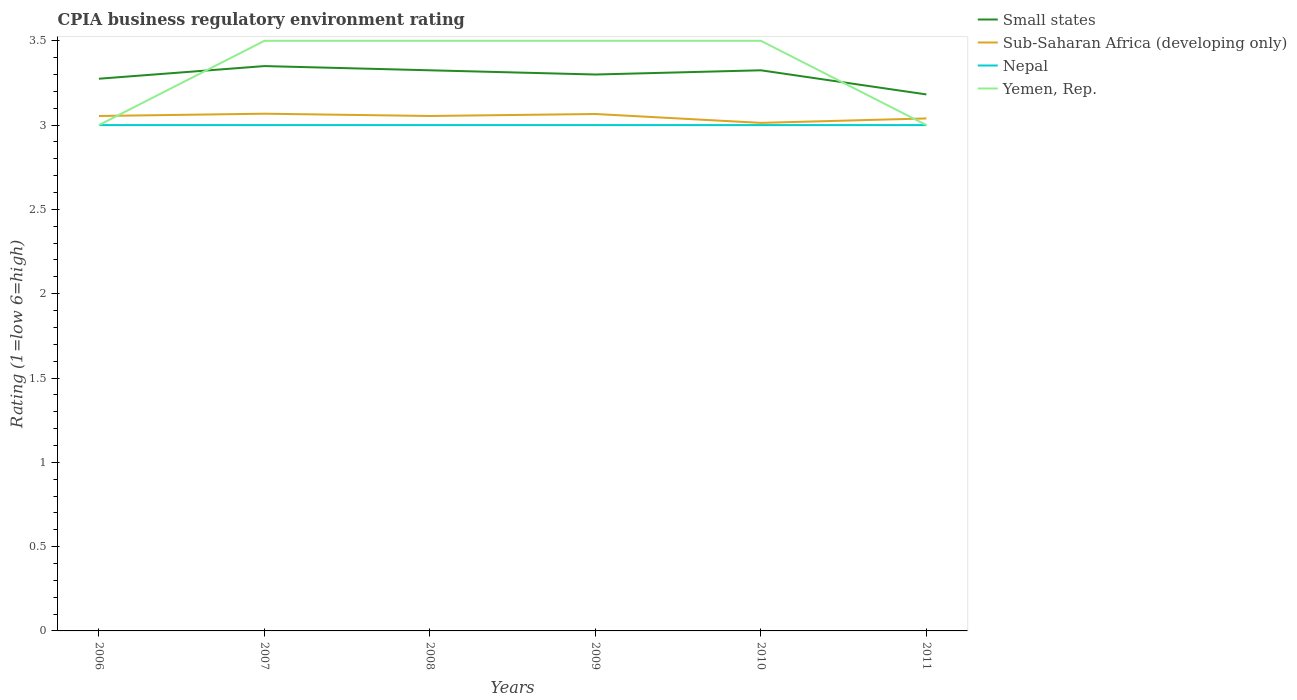How many different coloured lines are there?
Make the answer very short. 4. Does the line corresponding to Yemen, Rep. intersect with the line corresponding to Small states?
Your response must be concise. Yes. What is the total CPIA rating in Nepal in the graph?
Give a very brief answer. 0. What is the difference between the highest and the second highest CPIA rating in Small states?
Ensure brevity in your answer.  0.17. Is the CPIA rating in Small states strictly greater than the CPIA rating in Nepal over the years?
Give a very brief answer. No. How many lines are there?
Provide a succinct answer. 4. Are the values on the major ticks of Y-axis written in scientific E-notation?
Keep it short and to the point. No. Does the graph contain any zero values?
Make the answer very short. No. Does the graph contain grids?
Provide a short and direct response. No. Where does the legend appear in the graph?
Make the answer very short. Top right. How many legend labels are there?
Offer a terse response. 4. What is the title of the graph?
Offer a terse response. CPIA business regulatory environment rating. What is the label or title of the X-axis?
Your answer should be compact. Years. What is the label or title of the Y-axis?
Your answer should be very brief. Rating (1=low 6=high). What is the Rating (1=low 6=high) in Small states in 2006?
Give a very brief answer. 3.27. What is the Rating (1=low 6=high) of Sub-Saharan Africa (developing only) in 2006?
Offer a terse response. 3.05. What is the Rating (1=low 6=high) in Small states in 2007?
Provide a short and direct response. 3.35. What is the Rating (1=low 6=high) of Sub-Saharan Africa (developing only) in 2007?
Your answer should be very brief. 3.07. What is the Rating (1=low 6=high) of Yemen, Rep. in 2007?
Ensure brevity in your answer.  3.5. What is the Rating (1=low 6=high) in Small states in 2008?
Provide a short and direct response. 3.33. What is the Rating (1=low 6=high) in Sub-Saharan Africa (developing only) in 2008?
Give a very brief answer. 3.05. What is the Rating (1=low 6=high) in Nepal in 2008?
Give a very brief answer. 3. What is the Rating (1=low 6=high) in Sub-Saharan Africa (developing only) in 2009?
Offer a terse response. 3.07. What is the Rating (1=low 6=high) in Nepal in 2009?
Provide a short and direct response. 3. What is the Rating (1=low 6=high) of Small states in 2010?
Your answer should be very brief. 3.33. What is the Rating (1=low 6=high) of Sub-Saharan Africa (developing only) in 2010?
Ensure brevity in your answer.  3.01. What is the Rating (1=low 6=high) in Yemen, Rep. in 2010?
Make the answer very short. 3.5. What is the Rating (1=low 6=high) of Small states in 2011?
Keep it short and to the point. 3.18. What is the Rating (1=low 6=high) in Sub-Saharan Africa (developing only) in 2011?
Your answer should be compact. 3.04. What is the Rating (1=low 6=high) of Nepal in 2011?
Keep it short and to the point. 3. What is the Rating (1=low 6=high) of Yemen, Rep. in 2011?
Make the answer very short. 3. Across all years, what is the maximum Rating (1=low 6=high) in Small states?
Keep it short and to the point. 3.35. Across all years, what is the maximum Rating (1=low 6=high) in Sub-Saharan Africa (developing only)?
Ensure brevity in your answer.  3.07. Across all years, what is the maximum Rating (1=low 6=high) in Nepal?
Your answer should be compact. 3. Across all years, what is the minimum Rating (1=low 6=high) of Small states?
Your answer should be very brief. 3.18. Across all years, what is the minimum Rating (1=low 6=high) in Sub-Saharan Africa (developing only)?
Give a very brief answer. 3.01. Across all years, what is the minimum Rating (1=low 6=high) of Nepal?
Your response must be concise. 3. What is the total Rating (1=low 6=high) of Small states in the graph?
Your response must be concise. 19.76. What is the total Rating (1=low 6=high) in Sub-Saharan Africa (developing only) in the graph?
Make the answer very short. 18.29. What is the total Rating (1=low 6=high) in Nepal in the graph?
Your answer should be very brief. 18. What is the difference between the Rating (1=low 6=high) in Small states in 2006 and that in 2007?
Ensure brevity in your answer.  -0.07. What is the difference between the Rating (1=low 6=high) in Sub-Saharan Africa (developing only) in 2006 and that in 2007?
Offer a very short reply. -0.01. What is the difference between the Rating (1=low 6=high) in Nepal in 2006 and that in 2007?
Your answer should be compact. 0. What is the difference between the Rating (1=low 6=high) of Sub-Saharan Africa (developing only) in 2006 and that in 2008?
Provide a short and direct response. 0. What is the difference between the Rating (1=low 6=high) in Nepal in 2006 and that in 2008?
Offer a very short reply. 0. What is the difference between the Rating (1=low 6=high) of Small states in 2006 and that in 2009?
Provide a short and direct response. -0.03. What is the difference between the Rating (1=low 6=high) of Sub-Saharan Africa (developing only) in 2006 and that in 2009?
Keep it short and to the point. -0.01. What is the difference between the Rating (1=low 6=high) of Sub-Saharan Africa (developing only) in 2006 and that in 2010?
Offer a terse response. 0.04. What is the difference between the Rating (1=low 6=high) in Small states in 2006 and that in 2011?
Provide a short and direct response. 0.09. What is the difference between the Rating (1=low 6=high) of Sub-Saharan Africa (developing only) in 2006 and that in 2011?
Provide a short and direct response. 0.01. What is the difference between the Rating (1=low 6=high) in Small states in 2007 and that in 2008?
Offer a terse response. 0.03. What is the difference between the Rating (1=low 6=high) of Sub-Saharan Africa (developing only) in 2007 and that in 2008?
Provide a succinct answer. 0.01. What is the difference between the Rating (1=low 6=high) of Yemen, Rep. in 2007 and that in 2008?
Give a very brief answer. 0. What is the difference between the Rating (1=low 6=high) in Sub-Saharan Africa (developing only) in 2007 and that in 2009?
Give a very brief answer. 0. What is the difference between the Rating (1=low 6=high) in Nepal in 2007 and that in 2009?
Keep it short and to the point. 0. What is the difference between the Rating (1=low 6=high) of Small states in 2007 and that in 2010?
Provide a short and direct response. 0.03. What is the difference between the Rating (1=low 6=high) of Sub-Saharan Africa (developing only) in 2007 and that in 2010?
Offer a terse response. 0.05. What is the difference between the Rating (1=low 6=high) in Nepal in 2007 and that in 2010?
Provide a succinct answer. 0. What is the difference between the Rating (1=low 6=high) of Yemen, Rep. in 2007 and that in 2010?
Provide a short and direct response. 0. What is the difference between the Rating (1=low 6=high) in Small states in 2007 and that in 2011?
Your response must be concise. 0.17. What is the difference between the Rating (1=low 6=high) of Sub-Saharan Africa (developing only) in 2007 and that in 2011?
Ensure brevity in your answer.  0.03. What is the difference between the Rating (1=low 6=high) of Small states in 2008 and that in 2009?
Provide a short and direct response. 0.03. What is the difference between the Rating (1=low 6=high) in Sub-Saharan Africa (developing only) in 2008 and that in 2009?
Provide a short and direct response. -0.01. What is the difference between the Rating (1=low 6=high) of Sub-Saharan Africa (developing only) in 2008 and that in 2010?
Give a very brief answer. 0.04. What is the difference between the Rating (1=low 6=high) in Small states in 2008 and that in 2011?
Give a very brief answer. 0.14. What is the difference between the Rating (1=low 6=high) of Sub-Saharan Africa (developing only) in 2008 and that in 2011?
Your answer should be very brief. 0.01. What is the difference between the Rating (1=low 6=high) of Yemen, Rep. in 2008 and that in 2011?
Give a very brief answer. 0.5. What is the difference between the Rating (1=low 6=high) of Small states in 2009 and that in 2010?
Provide a succinct answer. -0.03. What is the difference between the Rating (1=low 6=high) of Sub-Saharan Africa (developing only) in 2009 and that in 2010?
Offer a terse response. 0.05. What is the difference between the Rating (1=low 6=high) of Yemen, Rep. in 2009 and that in 2010?
Offer a terse response. 0. What is the difference between the Rating (1=low 6=high) of Small states in 2009 and that in 2011?
Offer a very short reply. 0.12. What is the difference between the Rating (1=low 6=high) in Sub-Saharan Africa (developing only) in 2009 and that in 2011?
Offer a terse response. 0.03. What is the difference between the Rating (1=low 6=high) in Yemen, Rep. in 2009 and that in 2011?
Offer a very short reply. 0.5. What is the difference between the Rating (1=low 6=high) in Small states in 2010 and that in 2011?
Offer a terse response. 0.14. What is the difference between the Rating (1=low 6=high) in Sub-Saharan Africa (developing only) in 2010 and that in 2011?
Offer a very short reply. -0.03. What is the difference between the Rating (1=low 6=high) of Yemen, Rep. in 2010 and that in 2011?
Provide a succinct answer. 0.5. What is the difference between the Rating (1=low 6=high) in Small states in 2006 and the Rating (1=low 6=high) in Sub-Saharan Africa (developing only) in 2007?
Provide a succinct answer. 0.21. What is the difference between the Rating (1=low 6=high) of Small states in 2006 and the Rating (1=low 6=high) of Nepal in 2007?
Your answer should be very brief. 0.28. What is the difference between the Rating (1=low 6=high) of Small states in 2006 and the Rating (1=low 6=high) of Yemen, Rep. in 2007?
Your answer should be very brief. -0.23. What is the difference between the Rating (1=low 6=high) of Sub-Saharan Africa (developing only) in 2006 and the Rating (1=low 6=high) of Nepal in 2007?
Offer a very short reply. 0.05. What is the difference between the Rating (1=low 6=high) of Sub-Saharan Africa (developing only) in 2006 and the Rating (1=low 6=high) of Yemen, Rep. in 2007?
Your answer should be very brief. -0.45. What is the difference between the Rating (1=low 6=high) in Small states in 2006 and the Rating (1=low 6=high) in Sub-Saharan Africa (developing only) in 2008?
Provide a short and direct response. 0.22. What is the difference between the Rating (1=low 6=high) in Small states in 2006 and the Rating (1=low 6=high) in Nepal in 2008?
Provide a succinct answer. 0.28. What is the difference between the Rating (1=low 6=high) of Small states in 2006 and the Rating (1=low 6=high) of Yemen, Rep. in 2008?
Your answer should be compact. -0.23. What is the difference between the Rating (1=low 6=high) of Sub-Saharan Africa (developing only) in 2006 and the Rating (1=low 6=high) of Nepal in 2008?
Ensure brevity in your answer.  0.05. What is the difference between the Rating (1=low 6=high) in Sub-Saharan Africa (developing only) in 2006 and the Rating (1=low 6=high) in Yemen, Rep. in 2008?
Keep it short and to the point. -0.45. What is the difference between the Rating (1=low 6=high) of Nepal in 2006 and the Rating (1=low 6=high) of Yemen, Rep. in 2008?
Your answer should be very brief. -0.5. What is the difference between the Rating (1=low 6=high) of Small states in 2006 and the Rating (1=low 6=high) of Sub-Saharan Africa (developing only) in 2009?
Your answer should be compact. 0.21. What is the difference between the Rating (1=low 6=high) of Small states in 2006 and the Rating (1=low 6=high) of Nepal in 2009?
Offer a terse response. 0.28. What is the difference between the Rating (1=low 6=high) of Small states in 2006 and the Rating (1=low 6=high) of Yemen, Rep. in 2009?
Offer a very short reply. -0.23. What is the difference between the Rating (1=low 6=high) in Sub-Saharan Africa (developing only) in 2006 and the Rating (1=low 6=high) in Nepal in 2009?
Make the answer very short. 0.05. What is the difference between the Rating (1=low 6=high) in Sub-Saharan Africa (developing only) in 2006 and the Rating (1=low 6=high) in Yemen, Rep. in 2009?
Provide a succinct answer. -0.45. What is the difference between the Rating (1=low 6=high) in Nepal in 2006 and the Rating (1=low 6=high) in Yemen, Rep. in 2009?
Your response must be concise. -0.5. What is the difference between the Rating (1=low 6=high) in Small states in 2006 and the Rating (1=low 6=high) in Sub-Saharan Africa (developing only) in 2010?
Offer a very short reply. 0.26. What is the difference between the Rating (1=low 6=high) in Small states in 2006 and the Rating (1=low 6=high) in Nepal in 2010?
Your response must be concise. 0.28. What is the difference between the Rating (1=low 6=high) in Small states in 2006 and the Rating (1=low 6=high) in Yemen, Rep. in 2010?
Offer a terse response. -0.23. What is the difference between the Rating (1=low 6=high) in Sub-Saharan Africa (developing only) in 2006 and the Rating (1=low 6=high) in Nepal in 2010?
Make the answer very short. 0.05. What is the difference between the Rating (1=low 6=high) in Sub-Saharan Africa (developing only) in 2006 and the Rating (1=low 6=high) in Yemen, Rep. in 2010?
Your answer should be very brief. -0.45. What is the difference between the Rating (1=low 6=high) in Nepal in 2006 and the Rating (1=low 6=high) in Yemen, Rep. in 2010?
Your response must be concise. -0.5. What is the difference between the Rating (1=low 6=high) of Small states in 2006 and the Rating (1=low 6=high) of Sub-Saharan Africa (developing only) in 2011?
Ensure brevity in your answer.  0.24. What is the difference between the Rating (1=low 6=high) of Small states in 2006 and the Rating (1=low 6=high) of Nepal in 2011?
Your answer should be compact. 0.28. What is the difference between the Rating (1=low 6=high) in Small states in 2006 and the Rating (1=low 6=high) in Yemen, Rep. in 2011?
Your answer should be compact. 0.28. What is the difference between the Rating (1=low 6=high) of Sub-Saharan Africa (developing only) in 2006 and the Rating (1=low 6=high) of Nepal in 2011?
Your response must be concise. 0.05. What is the difference between the Rating (1=low 6=high) in Sub-Saharan Africa (developing only) in 2006 and the Rating (1=low 6=high) in Yemen, Rep. in 2011?
Keep it short and to the point. 0.05. What is the difference between the Rating (1=low 6=high) of Small states in 2007 and the Rating (1=low 6=high) of Sub-Saharan Africa (developing only) in 2008?
Offer a terse response. 0.3. What is the difference between the Rating (1=low 6=high) in Sub-Saharan Africa (developing only) in 2007 and the Rating (1=low 6=high) in Nepal in 2008?
Provide a succinct answer. 0.07. What is the difference between the Rating (1=low 6=high) in Sub-Saharan Africa (developing only) in 2007 and the Rating (1=low 6=high) in Yemen, Rep. in 2008?
Your response must be concise. -0.43. What is the difference between the Rating (1=low 6=high) in Nepal in 2007 and the Rating (1=low 6=high) in Yemen, Rep. in 2008?
Offer a very short reply. -0.5. What is the difference between the Rating (1=low 6=high) in Small states in 2007 and the Rating (1=low 6=high) in Sub-Saharan Africa (developing only) in 2009?
Give a very brief answer. 0.28. What is the difference between the Rating (1=low 6=high) in Small states in 2007 and the Rating (1=low 6=high) in Yemen, Rep. in 2009?
Offer a very short reply. -0.15. What is the difference between the Rating (1=low 6=high) of Sub-Saharan Africa (developing only) in 2007 and the Rating (1=low 6=high) of Nepal in 2009?
Provide a succinct answer. 0.07. What is the difference between the Rating (1=low 6=high) of Sub-Saharan Africa (developing only) in 2007 and the Rating (1=low 6=high) of Yemen, Rep. in 2009?
Offer a terse response. -0.43. What is the difference between the Rating (1=low 6=high) of Small states in 2007 and the Rating (1=low 6=high) of Sub-Saharan Africa (developing only) in 2010?
Your answer should be very brief. 0.34. What is the difference between the Rating (1=low 6=high) in Small states in 2007 and the Rating (1=low 6=high) in Nepal in 2010?
Ensure brevity in your answer.  0.35. What is the difference between the Rating (1=low 6=high) of Small states in 2007 and the Rating (1=low 6=high) of Yemen, Rep. in 2010?
Provide a short and direct response. -0.15. What is the difference between the Rating (1=low 6=high) in Sub-Saharan Africa (developing only) in 2007 and the Rating (1=low 6=high) in Nepal in 2010?
Keep it short and to the point. 0.07. What is the difference between the Rating (1=low 6=high) in Sub-Saharan Africa (developing only) in 2007 and the Rating (1=low 6=high) in Yemen, Rep. in 2010?
Ensure brevity in your answer.  -0.43. What is the difference between the Rating (1=low 6=high) in Nepal in 2007 and the Rating (1=low 6=high) in Yemen, Rep. in 2010?
Keep it short and to the point. -0.5. What is the difference between the Rating (1=low 6=high) of Small states in 2007 and the Rating (1=low 6=high) of Sub-Saharan Africa (developing only) in 2011?
Provide a short and direct response. 0.31. What is the difference between the Rating (1=low 6=high) in Small states in 2007 and the Rating (1=low 6=high) in Nepal in 2011?
Offer a very short reply. 0.35. What is the difference between the Rating (1=low 6=high) in Sub-Saharan Africa (developing only) in 2007 and the Rating (1=low 6=high) in Nepal in 2011?
Ensure brevity in your answer.  0.07. What is the difference between the Rating (1=low 6=high) of Sub-Saharan Africa (developing only) in 2007 and the Rating (1=low 6=high) of Yemen, Rep. in 2011?
Offer a terse response. 0.07. What is the difference between the Rating (1=low 6=high) in Nepal in 2007 and the Rating (1=low 6=high) in Yemen, Rep. in 2011?
Offer a very short reply. 0. What is the difference between the Rating (1=low 6=high) in Small states in 2008 and the Rating (1=low 6=high) in Sub-Saharan Africa (developing only) in 2009?
Provide a short and direct response. 0.26. What is the difference between the Rating (1=low 6=high) in Small states in 2008 and the Rating (1=low 6=high) in Nepal in 2009?
Make the answer very short. 0.33. What is the difference between the Rating (1=low 6=high) in Small states in 2008 and the Rating (1=low 6=high) in Yemen, Rep. in 2009?
Your answer should be compact. -0.17. What is the difference between the Rating (1=low 6=high) of Sub-Saharan Africa (developing only) in 2008 and the Rating (1=low 6=high) of Nepal in 2009?
Offer a terse response. 0.05. What is the difference between the Rating (1=low 6=high) of Sub-Saharan Africa (developing only) in 2008 and the Rating (1=low 6=high) of Yemen, Rep. in 2009?
Offer a very short reply. -0.45. What is the difference between the Rating (1=low 6=high) in Small states in 2008 and the Rating (1=low 6=high) in Sub-Saharan Africa (developing only) in 2010?
Provide a short and direct response. 0.31. What is the difference between the Rating (1=low 6=high) in Small states in 2008 and the Rating (1=low 6=high) in Nepal in 2010?
Offer a terse response. 0.33. What is the difference between the Rating (1=low 6=high) of Small states in 2008 and the Rating (1=low 6=high) of Yemen, Rep. in 2010?
Offer a terse response. -0.17. What is the difference between the Rating (1=low 6=high) in Sub-Saharan Africa (developing only) in 2008 and the Rating (1=low 6=high) in Nepal in 2010?
Your response must be concise. 0.05. What is the difference between the Rating (1=low 6=high) in Sub-Saharan Africa (developing only) in 2008 and the Rating (1=low 6=high) in Yemen, Rep. in 2010?
Offer a terse response. -0.45. What is the difference between the Rating (1=low 6=high) of Nepal in 2008 and the Rating (1=low 6=high) of Yemen, Rep. in 2010?
Provide a short and direct response. -0.5. What is the difference between the Rating (1=low 6=high) in Small states in 2008 and the Rating (1=low 6=high) in Sub-Saharan Africa (developing only) in 2011?
Give a very brief answer. 0.29. What is the difference between the Rating (1=low 6=high) in Small states in 2008 and the Rating (1=low 6=high) in Nepal in 2011?
Offer a terse response. 0.33. What is the difference between the Rating (1=low 6=high) of Small states in 2008 and the Rating (1=low 6=high) of Yemen, Rep. in 2011?
Make the answer very short. 0.33. What is the difference between the Rating (1=low 6=high) in Sub-Saharan Africa (developing only) in 2008 and the Rating (1=low 6=high) in Nepal in 2011?
Your answer should be very brief. 0.05. What is the difference between the Rating (1=low 6=high) of Sub-Saharan Africa (developing only) in 2008 and the Rating (1=low 6=high) of Yemen, Rep. in 2011?
Your response must be concise. 0.05. What is the difference between the Rating (1=low 6=high) in Small states in 2009 and the Rating (1=low 6=high) in Sub-Saharan Africa (developing only) in 2010?
Offer a terse response. 0.29. What is the difference between the Rating (1=low 6=high) of Small states in 2009 and the Rating (1=low 6=high) of Nepal in 2010?
Give a very brief answer. 0.3. What is the difference between the Rating (1=low 6=high) in Small states in 2009 and the Rating (1=low 6=high) in Yemen, Rep. in 2010?
Ensure brevity in your answer.  -0.2. What is the difference between the Rating (1=low 6=high) in Sub-Saharan Africa (developing only) in 2009 and the Rating (1=low 6=high) in Nepal in 2010?
Give a very brief answer. 0.07. What is the difference between the Rating (1=low 6=high) of Sub-Saharan Africa (developing only) in 2009 and the Rating (1=low 6=high) of Yemen, Rep. in 2010?
Ensure brevity in your answer.  -0.43. What is the difference between the Rating (1=low 6=high) in Small states in 2009 and the Rating (1=low 6=high) in Sub-Saharan Africa (developing only) in 2011?
Offer a very short reply. 0.26. What is the difference between the Rating (1=low 6=high) in Small states in 2009 and the Rating (1=low 6=high) in Yemen, Rep. in 2011?
Offer a very short reply. 0.3. What is the difference between the Rating (1=low 6=high) in Sub-Saharan Africa (developing only) in 2009 and the Rating (1=low 6=high) in Nepal in 2011?
Provide a short and direct response. 0.07. What is the difference between the Rating (1=low 6=high) in Sub-Saharan Africa (developing only) in 2009 and the Rating (1=low 6=high) in Yemen, Rep. in 2011?
Give a very brief answer. 0.07. What is the difference between the Rating (1=low 6=high) in Nepal in 2009 and the Rating (1=low 6=high) in Yemen, Rep. in 2011?
Provide a short and direct response. 0. What is the difference between the Rating (1=low 6=high) of Small states in 2010 and the Rating (1=low 6=high) of Sub-Saharan Africa (developing only) in 2011?
Keep it short and to the point. 0.29. What is the difference between the Rating (1=low 6=high) of Small states in 2010 and the Rating (1=low 6=high) of Nepal in 2011?
Keep it short and to the point. 0.33. What is the difference between the Rating (1=low 6=high) of Small states in 2010 and the Rating (1=low 6=high) of Yemen, Rep. in 2011?
Your response must be concise. 0.33. What is the difference between the Rating (1=low 6=high) of Sub-Saharan Africa (developing only) in 2010 and the Rating (1=low 6=high) of Nepal in 2011?
Offer a very short reply. 0.01. What is the difference between the Rating (1=low 6=high) of Sub-Saharan Africa (developing only) in 2010 and the Rating (1=low 6=high) of Yemen, Rep. in 2011?
Offer a very short reply. 0.01. What is the average Rating (1=low 6=high) of Small states per year?
Make the answer very short. 3.29. What is the average Rating (1=low 6=high) of Sub-Saharan Africa (developing only) per year?
Your response must be concise. 3.05. In the year 2006, what is the difference between the Rating (1=low 6=high) in Small states and Rating (1=low 6=high) in Sub-Saharan Africa (developing only)?
Your answer should be compact. 0.22. In the year 2006, what is the difference between the Rating (1=low 6=high) in Small states and Rating (1=low 6=high) in Nepal?
Provide a succinct answer. 0.28. In the year 2006, what is the difference between the Rating (1=low 6=high) in Small states and Rating (1=low 6=high) in Yemen, Rep.?
Ensure brevity in your answer.  0.28. In the year 2006, what is the difference between the Rating (1=low 6=high) in Sub-Saharan Africa (developing only) and Rating (1=low 6=high) in Nepal?
Keep it short and to the point. 0.05. In the year 2006, what is the difference between the Rating (1=low 6=high) in Sub-Saharan Africa (developing only) and Rating (1=low 6=high) in Yemen, Rep.?
Offer a terse response. 0.05. In the year 2006, what is the difference between the Rating (1=low 6=high) of Nepal and Rating (1=low 6=high) of Yemen, Rep.?
Your answer should be compact. 0. In the year 2007, what is the difference between the Rating (1=low 6=high) of Small states and Rating (1=low 6=high) of Sub-Saharan Africa (developing only)?
Your answer should be compact. 0.28. In the year 2007, what is the difference between the Rating (1=low 6=high) of Sub-Saharan Africa (developing only) and Rating (1=low 6=high) of Nepal?
Your answer should be compact. 0.07. In the year 2007, what is the difference between the Rating (1=low 6=high) in Sub-Saharan Africa (developing only) and Rating (1=low 6=high) in Yemen, Rep.?
Your answer should be very brief. -0.43. In the year 2007, what is the difference between the Rating (1=low 6=high) in Nepal and Rating (1=low 6=high) in Yemen, Rep.?
Offer a very short reply. -0.5. In the year 2008, what is the difference between the Rating (1=low 6=high) in Small states and Rating (1=low 6=high) in Sub-Saharan Africa (developing only)?
Provide a short and direct response. 0.27. In the year 2008, what is the difference between the Rating (1=low 6=high) in Small states and Rating (1=low 6=high) in Nepal?
Your answer should be very brief. 0.33. In the year 2008, what is the difference between the Rating (1=low 6=high) in Small states and Rating (1=low 6=high) in Yemen, Rep.?
Offer a terse response. -0.17. In the year 2008, what is the difference between the Rating (1=low 6=high) in Sub-Saharan Africa (developing only) and Rating (1=low 6=high) in Nepal?
Provide a succinct answer. 0.05. In the year 2008, what is the difference between the Rating (1=low 6=high) of Sub-Saharan Africa (developing only) and Rating (1=low 6=high) of Yemen, Rep.?
Provide a short and direct response. -0.45. In the year 2009, what is the difference between the Rating (1=low 6=high) of Small states and Rating (1=low 6=high) of Sub-Saharan Africa (developing only)?
Your response must be concise. 0.23. In the year 2009, what is the difference between the Rating (1=low 6=high) of Sub-Saharan Africa (developing only) and Rating (1=low 6=high) of Nepal?
Keep it short and to the point. 0.07. In the year 2009, what is the difference between the Rating (1=low 6=high) in Sub-Saharan Africa (developing only) and Rating (1=low 6=high) in Yemen, Rep.?
Give a very brief answer. -0.43. In the year 2009, what is the difference between the Rating (1=low 6=high) in Nepal and Rating (1=low 6=high) in Yemen, Rep.?
Make the answer very short. -0.5. In the year 2010, what is the difference between the Rating (1=low 6=high) in Small states and Rating (1=low 6=high) in Sub-Saharan Africa (developing only)?
Your answer should be very brief. 0.31. In the year 2010, what is the difference between the Rating (1=low 6=high) in Small states and Rating (1=low 6=high) in Nepal?
Your response must be concise. 0.33. In the year 2010, what is the difference between the Rating (1=low 6=high) of Small states and Rating (1=low 6=high) of Yemen, Rep.?
Offer a terse response. -0.17. In the year 2010, what is the difference between the Rating (1=low 6=high) in Sub-Saharan Africa (developing only) and Rating (1=low 6=high) in Nepal?
Offer a very short reply. 0.01. In the year 2010, what is the difference between the Rating (1=low 6=high) in Sub-Saharan Africa (developing only) and Rating (1=low 6=high) in Yemen, Rep.?
Offer a very short reply. -0.49. In the year 2011, what is the difference between the Rating (1=low 6=high) in Small states and Rating (1=low 6=high) in Sub-Saharan Africa (developing only)?
Your answer should be very brief. 0.14. In the year 2011, what is the difference between the Rating (1=low 6=high) of Small states and Rating (1=low 6=high) of Nepal?
Provide a short and direct response. 0.18. In the year 2011, what is the difference between the Rating (1=low 6=high) in Small states and Rating (1=low 6=high) in Yemen, Rep.?
Give a very brief answer. 0.18. In the year 2011, what is the difference between the Rating (1=low 6=high) in Sub-Saharan Africa (developing only) and Rating (1=low 6=high) in Nepal?
Provide a short and direct response. 0.04. In the year 2011, what is the difference between the Rating (1=low 6=high) in Sub-Saharan Africa (developing only) and Rating (1=low 6=high) in Yemen, Rep.?
Your answer should be compact. 0.04. In the year 2011, what is the difference between the Rating (1=low 6=high) in Nepal and Rating (1=low 6=high) in Yemen, Rep.?
Keep it short and to the point. 0. What is the ratio of the Rating (1=low 6=high) in Small states in 2006 to that in 2007?
Provide a short and direct response. 0.98. What is the ratio of the Rating (1=low 6=high) in Nepal in 2006 to that in 2007?
Give a very brief answer. 1. What is the ratio of the Rating (1=low 6=high) in Yemen, Rep. in 2006 to that in 2007?
Your answer should be compact. 0.86. What is the ratio of the Rating (1=low 6=high) in Small states in 2006 to that in 2008?
Give a very brief answer. 0.98. What is the ratio of the Rating (1=low 6=high) of Sub-Saharan Africa (developing only) in 2006 to that in 2008?
Offer a terse response. 1. What is the ratio of the Rating (1=low 6=high) of Yemen, Rep. in 2006 to that in 2008?
Offer a terse response. 0.86. What is the ratio of the Rating (1=low 6=high) of Small states in 2006 to that in 2009?
Give a very brief answer. 0.99. What is the ratio of the Rating (1=low 6=high) in Sub-Saharan Africa (developing only) in 2006 to that in 2009?
Your response must be concise. 1. What is the ratio of the Rating (1=low 6=high) in Sub-Saharan Africa (developing only) in 2006 to that in 2010?
Offer a terse response. 1.01. What is the ratio of the Rating (1=low 6=high) of Yemen, Rep. in 2006 to that in 2010?
Your response must be concise. 0.86. What is the ratio of the Rating (1=low 6=high) of Small states in 2006 to that in 2011?
Make the answer very short. 1.03. What is the ratio of the Rating (1=low 6=high) in Sub-Saharan Africa (developing only) in 2006 to that in 2011?
Offer a terse response. 1. What is the ratio of the Rating (1=low 6=high) of Nepal in 2006 to that in 2011?
Make the answer very short. 1. What is the ratio of the Rating (1=low 6=high) in Small states in 2007 to that in 2008?
Your response must be concise. 1.01. What is the ratio of the Rating (1=low 6=high) in Sub-Saharan Africa (developing only) in 2007 to that in 2008?
Offer a terse response. 1. What is the ratio of the Rating (1=low 6=high) in Nepal in 2007 to that in 2008?
Provide a succinct answer. 1. What is the ratio of the Rating (1=low 6=high) of Small states in 2007 to that in 2009?
Keep it short and to the point. 1.02. What is the ratio of the Rating (1=low 6=high) of Small states in 2007 to that in 2010?
Offer a very short reply. 1.01. What is the ratio of the Rating (1=low 6=high) of Sub-Saharan Africa (developing only) in 2007 to that in 2010?
Make the answer very short. 1.02. What is the ratio of the Rating (1=low 6=high) in Nepal in 2007 to that in 2010?
Offer a terse response. 1. What is the ratio of the Rating (1=low 6=high) of Small states in 2007 to that in 2011?
Your answer should be compact. 1.05. What is the ratio of the Rating (1=low 6=high) of Sub-Saharan Africa (developing only) in 2007 to that in 2011?
Your answer should be compact. 1.01. What is the ratio of the Rating (1=low 6=high) in Yemen, Rep. in 2007 to that in 2011?
Provide a short and direct response. 1.17. What is the ratio of the Rating (1=low 6=high) of Small states in 2008 to that in 2009?
Your answer should be very brief. 1.01. What is the ratio of the Rating (1=low 6=high) of Yemen, Rep. in 2008 to that in 2009?
Ensure brevity in your answer.  1. What is the ratio of the Rating (1=low 6=high) in Small states in 2008 to that in 2010?
Your answer should be very brief. 1. What is the ratio of the Rating (1=low 6=high) in Sub-Saharan Africa (developing only) in 2008 to that in 2010?
Make the answer very short. 1.01. What is the ratio of the Rating (1=low 6=high) of Nepal in 2008 to that in 2010?
Your answer should be very brief. 1. What is the ratio of the Rating (1=low 6=high) in Yemen, Rep. in 2008 to that in 2010?
Keep it short and to the point. 1. What is the ratio of the Rating (1=low 6=high) of Small states in 2008 to that in 2011?
Make the answer very short. 1.04. What is the ratio of the Rating (1=low 6=high) in Small states in 2009 to that in 2010?
Your answer should be compact. 0.99. What is the ratio of the Rating (1=low 6=high) of Sub-Saharan Africa (developing only) in 2009 to that in 2010?
Offer a very short reply. 1.02. What is the ratio of the Rating (1=low 6=high) of Nepal in 2009 to that in 2010?
Your response must be concise. 1. What is the ratio of the Rating (1=low 6=high) of Yemen, Rep. in 2009 to that in 2010?
Your answer should be very brief. 1. What is the ratio of the Rating (1=low 6=high) in Small states in 2009 to that in 2011?
Ensure brevity in your answer.  1.04. What is the ratio of the Rating (1=low 6=high) of Sub-Saharan Africa (developing only) in 2009 to that in 2011?
Keep it short and to the point. 1.01. What is the ratio of the Rating (1=low 6=high) of Yemen, Rep. in 2009 to that in 2011?
Keep it short and to the point. 1.17. What is the ratio of the Rating (1=low 6=high) in Small states in 2010 to that in 2011?
Provide a short and direct response. 1.04. What is the ratio of the Rating (1=low 6=high) of Sub-Saharan Africa (developing only) in 2010 to that in 2011?
Keep it short and to the point. 0.99. What is the difference between the highest and the second highest Rating (1=low 6=high) in Small states?
Offer a terse response. 0.03. What is the difference between the highest and the second highest Rating (1=low 6=high) in Sub-Saharan Africa (developing only)?
Make the answer very short. 0. What is the difference between the highest and the second highest Rating (1=low 6=high) in Yemen, Rep.?
Ensure brevity in your answer.  0. What is the difference between the highest and the lowest Rating (1=low 6=high) of Small states?
Offer a terse response. 0.17. What is the difference between the highest and the lowest Rating (1=low 6=high) in Sub-Saharan Africa (developing only)?
Your response must be concise. 0.05. 